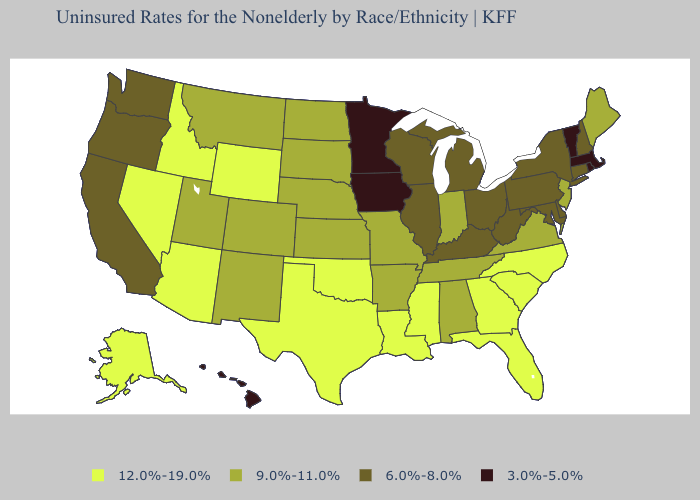Name the states that have a value in the range 12.0%-19.0%?
Write a very short answer. Alaska, Arizona, Florida, Georgia, Idaho, Louisiana, Mississippi, Nevada, North Carolina, Oklahoma, South Carolina, Texas, Wyoming. Does Minnesota have the lowest value in the MidWest?
Short answer required. Yes. Is the legend a continuous bar?
Give a very brief answer. No. What is the value of Texas?
Be succinct. 12.0%-19.0%. Does Wyoming have a higher value than Louisiana?
Write a very short answer. No. What is the lowest value in the Northeast?
Answer briefly. 3.0%-5.0%. Does Montana have the highest value in the USA?
Give a very brief answer. No. Does Montana have the lowest value in the USA?
Answer briefly. No. Among the states that border Alabama , does Georgia have the highest value?
Be succinct. Yes. Does Idaho have the highest value in the West?
Short answer required. Yes. What is the value of Rhode Island?
Short answer required. 3.0%-5.0%. Name the states that have a value in the range 9.0%-11.0%?
Keep it brief. Alabama, Arkansas, Colorado, Indiana, Kansas, Maine, Missouri, Montana, Nebraska, New Jersey, New Mexico, North Dakota, South Dakota, Tennessee, Utah, Virginia. Which states have the lowest value in the USA?
Short answer required. Hawaii, Iowa, Massachusetts, Minnesota, Rhode Island, Vermont. Which states have the highest value in the USA?
Concise answer only. Alaska, Arizona, Florida, Georgia, Idaho, Louisiana, Mississippi, Nevada, North Carolina, Oklahoma, South Carolina, Texas, Wyoming. 